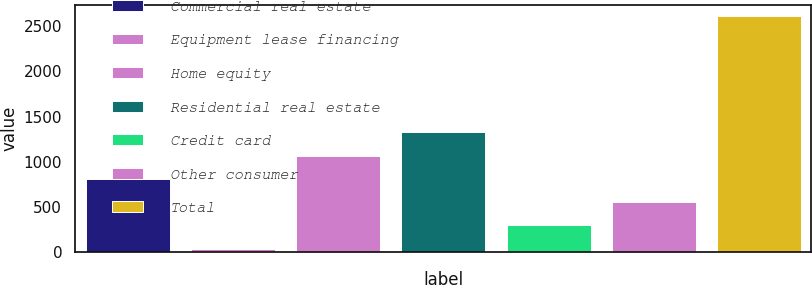Convert chart. <chart><loc_0><loc_0><loc_500><loc_500><bar_chart><fcel>Commercial real estate<fcel>Equipment lease financing<fcel>Home equity<fcel>Residential real estate<fcel>Credit card<fcel>Other consumer<fcel>Total<nl><fcel>808.5<fcel>36<fcel>1066<fcel>1323.5<fcel>293.5<fcel>551<fcel>2611<nl></chart> 